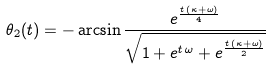<formula> <loc_0><loc_0><loc_500><loc_500>\theta _ { 2 } ( t ) = - \arcsin \frac { e ^ { \frac { t \, \left ( \kappa + \omega \right ) } { 4 } } } { { \sqrt { 1 + e ^ { t \, \omega } + e ^ { \frac { t \, \left ( \kappa + \omega \right ) } { 2 } } } } }</formula> 